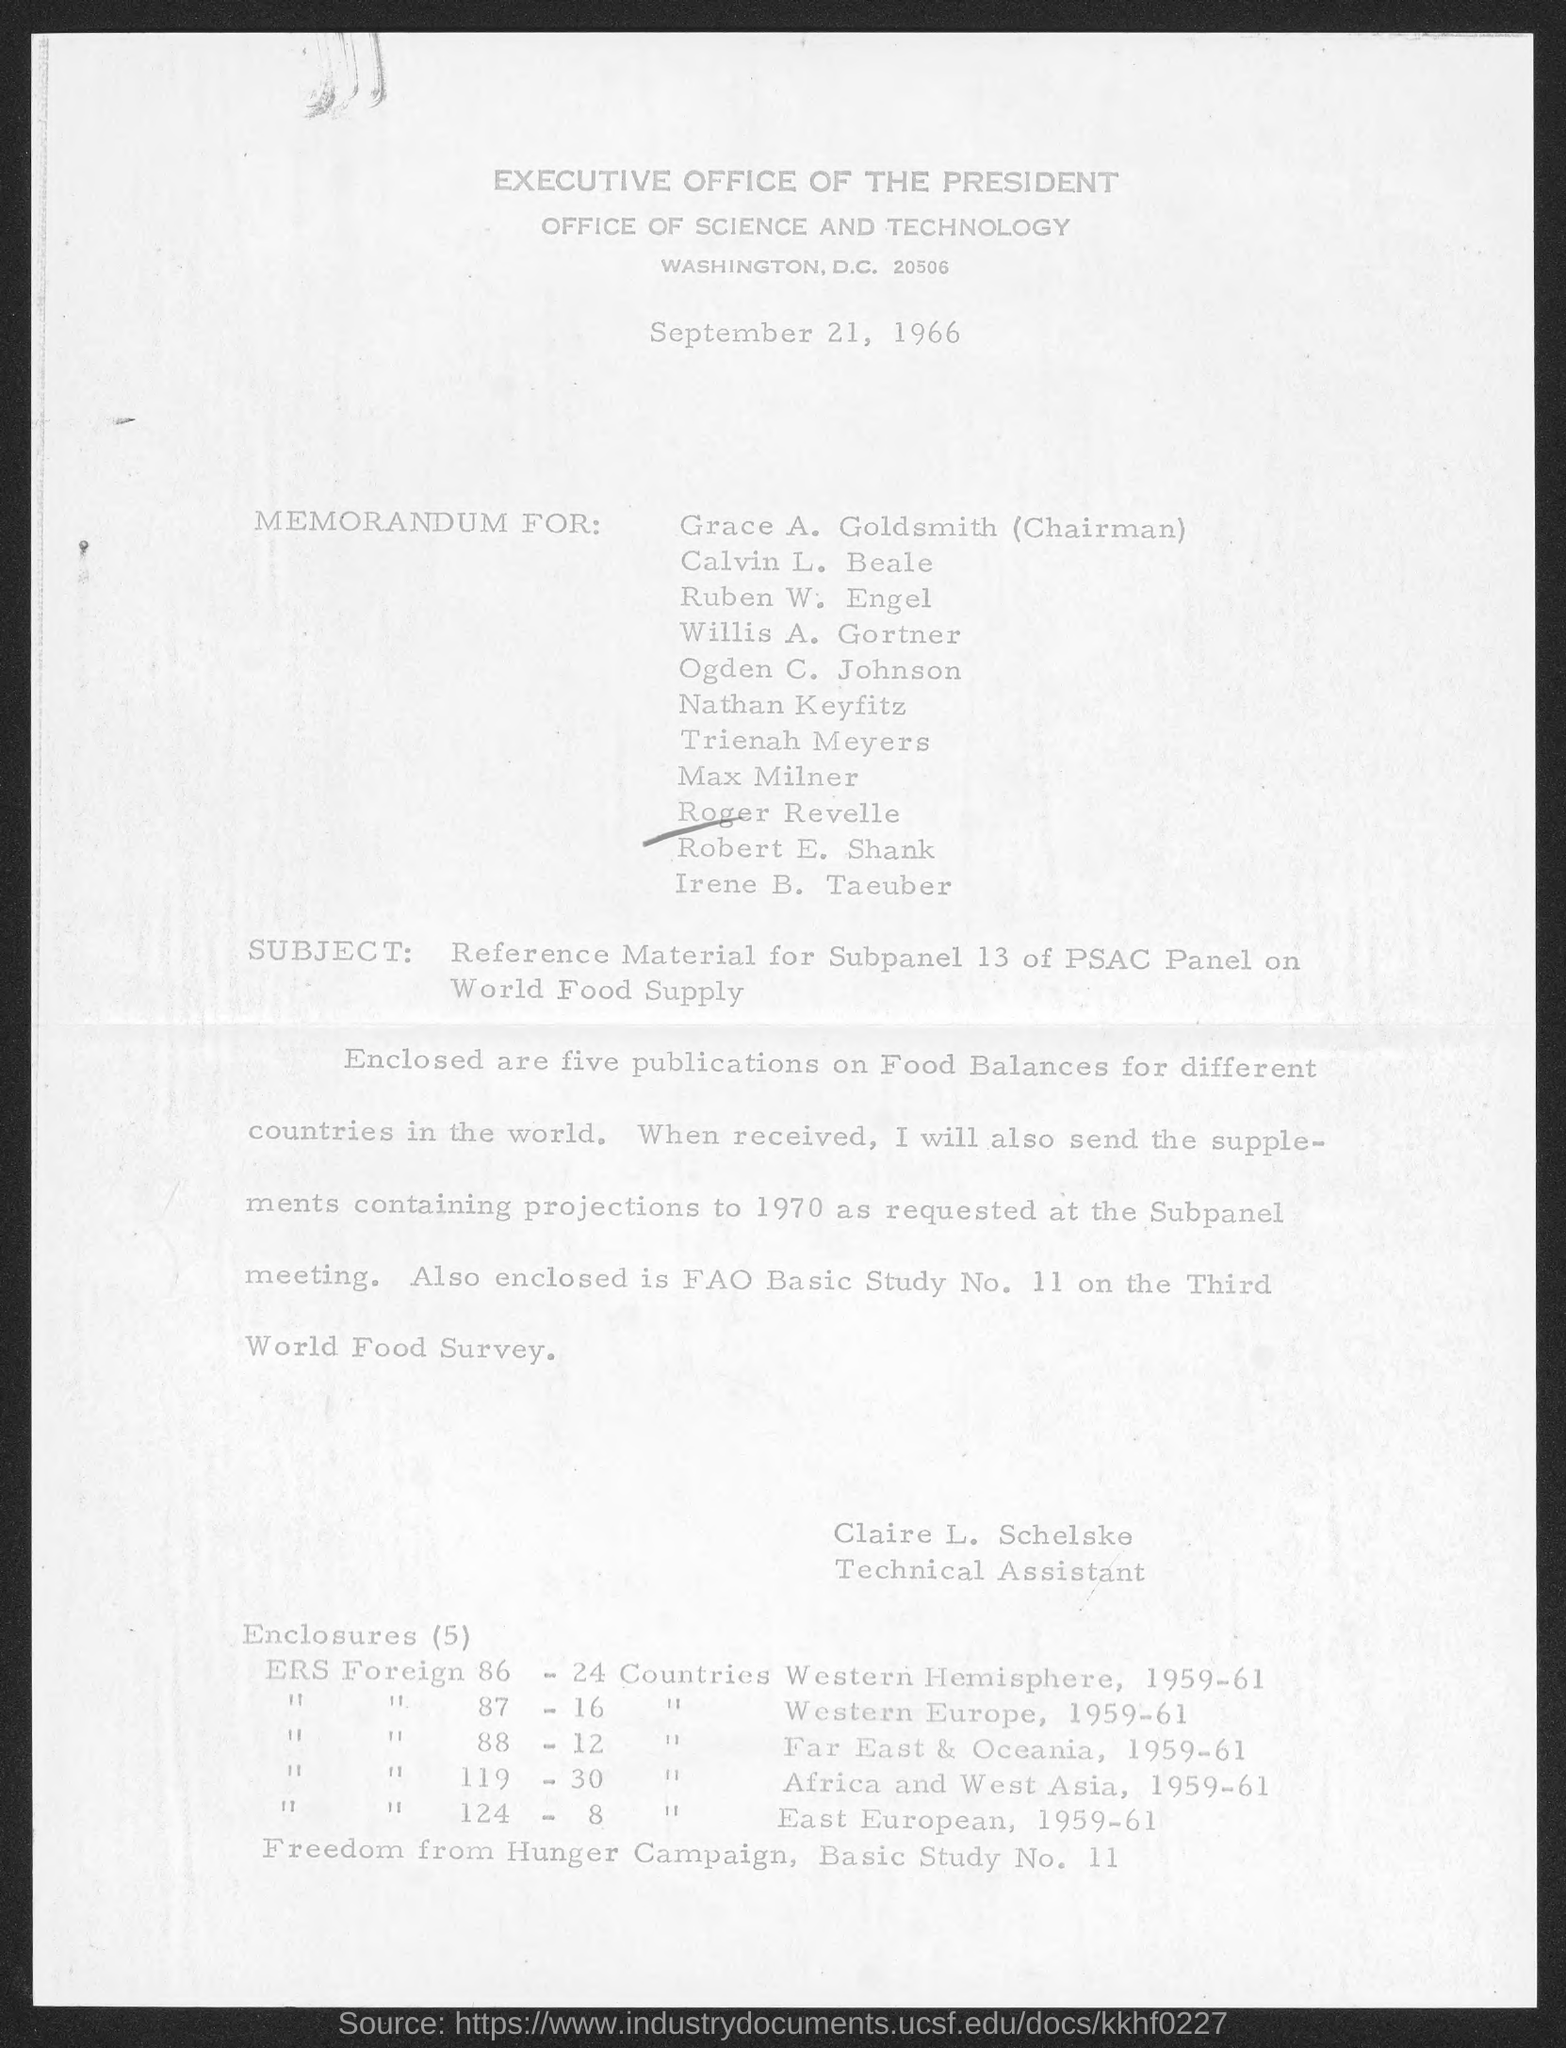List a handful of essential elements in this visual. The enclosed documents contain five publications on Food Balances. The subject of the document is reference material for subpanel 13 of the PSAC Panel on world food supply. The document is dated September 21, 1966. Claire L. Schelske is the Technical Assistant. 